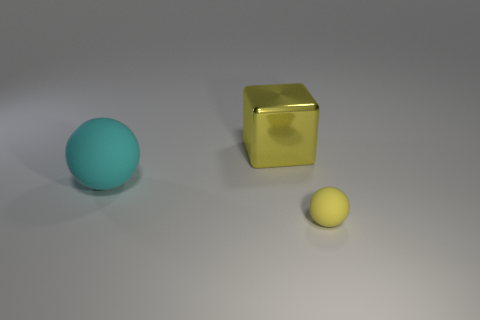What is the shape of the other small thing that is the same color as the metal object?
Make the answer very short. Sphere. Is the sphere that is left of the tiny yellow rubber object made of the same material as the cube that is behind the small yellow object?
Offer a very short reply. No. Are there more small spheres than large blue metallic cylinders?
Give a very brief answer. Yes. Is there any other thing that is the same color as the shiny block?
Keep it short and to the point. Yes. Do the big yellow thing and the big ball have the same material?
Your response must be concise. No. Are there fewer small yellow objects than green metallic blocks?
Provide a short and direct response. No. Do the big rubber object and the large metallic object have the same shape?
Provide a succinct answer. No. The small ball is what color?
Your answer should be very brief. Yellow. How many other things are there of the same material as the cyan object?
Ensure brevity in your answer.  1. How many yellow objects are large rubber balls or blocks?
Your answer should be compact. 1. 